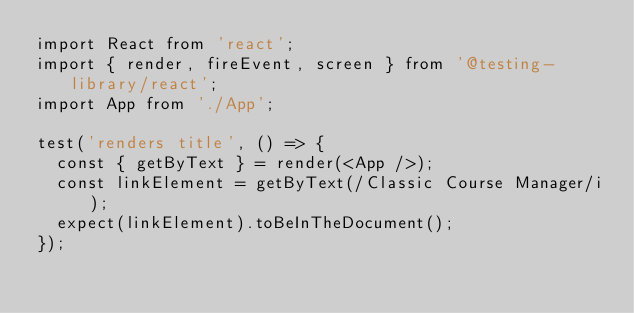<code> <loc_0><loc_0><loc_500><loc_500><_TypeScript_>import React from 'react';
import { render, fireEvent, screen } from '@testing-library/react';
import App from './App';

test('renders title', () => {
  const { getByText } = render(<App />);
  const linkElement = getByText(/Classic Course Manager/i);
  expect(linkElement).toBeInTheDocument();
});</code> 